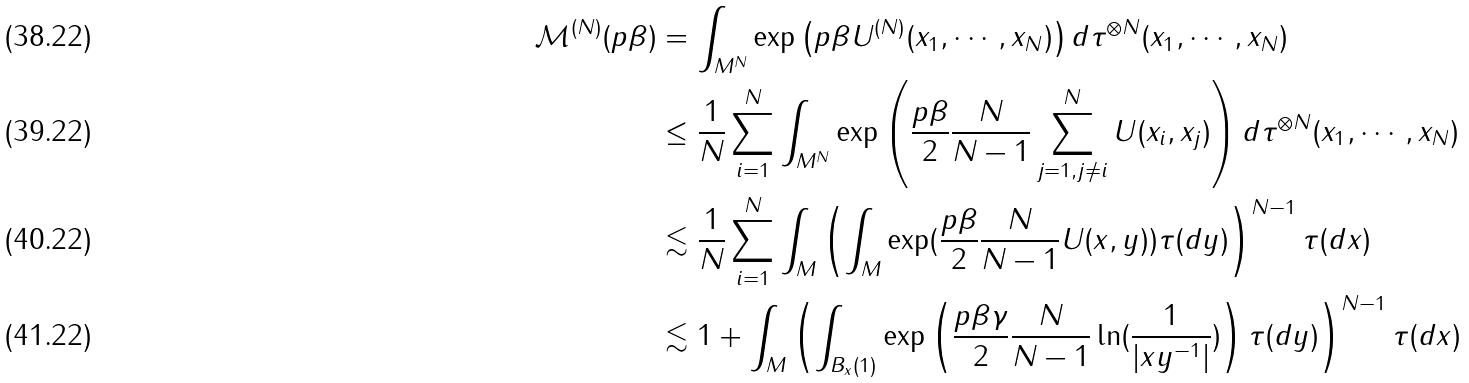<formula> <loc_0><loc_0><loc_500><loc_500>\mathcal { M } ^ { ( N ) } ( p \beta ) & = \int _ { M ^ { N } } \exp \left ( p \beta U ^ { ( N ) } ( x _ { 1 } , \cdots , x _ { N } ) \right ) d \tau ^ { \otimes N } ( x _ { 1 } , \cdots , x _ { N } ) \\ & \leq \frac { 1 } { N } \sum _ { i = 1 } ^ { N } \int _ { M ^ { N } } \exp \left ( \frac { p \beta } { 2 } \frac { N } { N - 1 } \sum _ { j = 1 , j \not = i } ^ { N } U ( x _ { i } , x _ { j } ) \right ) d \tau ^ { \otimes N } ( x _ { 1 } , \cdots , x _ { N } ) \\ & \lesssim \frac { 1 } { N } \sum _ { i = 1 } ^ { N } \int _ { M } \left ( \int _ { M } \exp ( \frac { p \beta } { 2 } \frac { N } { N - 1 } U ( x , y ) ) \tau ( d y ) \right ) ^ { N - 1 } \tau ( d x ) \\ & \lesssim 1 + \int _ { M } \left ( \int _ { B _ { x } ( 1 ) } \exp \left ( \frac { p \beta \gamma } { 2 } \frac { N } { N - 1 } \ln ( \frac { 1 } { | x y ^ { - 1 } | } ) \right ) \tau ( d y ) \right ) ^ { N - 1 } \tau ( d x )</formula> 